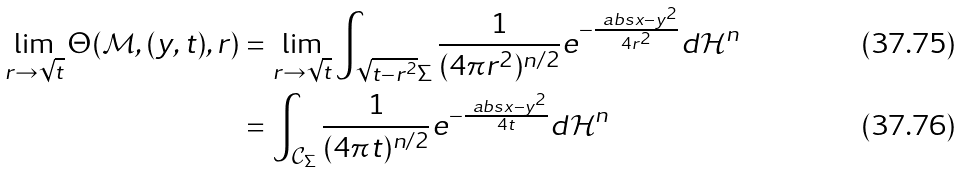Convert formula to latex. <formula><loc_0><loc_0><loc_500><loc_500>\lim _ { r \to \sqrt { t } } \Theta ( \mathcal { M } , ( y , t ) , r ) & = \lim _ { r \to \sqrt { t } } \int _ { \sqrt { t - r ^ { 2 } } \Sigma } \frac { 1 } { ( 4 \pi r ^ { 2 } ) ^ { n / 2 } } e ^ { - \frac { \ a b s { x - y } ^ { 2 } } { 4 r ^ { 2 } } } d \mathcal { H } ^ { n } \\ & = \int _ { \mathcal { C } _ { \Sigma } } \frac { 1 } { ( 4 \pi t ) ^ { n / 2 } } e ^ { - \frac { \ a b s { x - y } ^ { 2 } } { 4 t } } d \mathcal { H } ^ { n }</formula> 